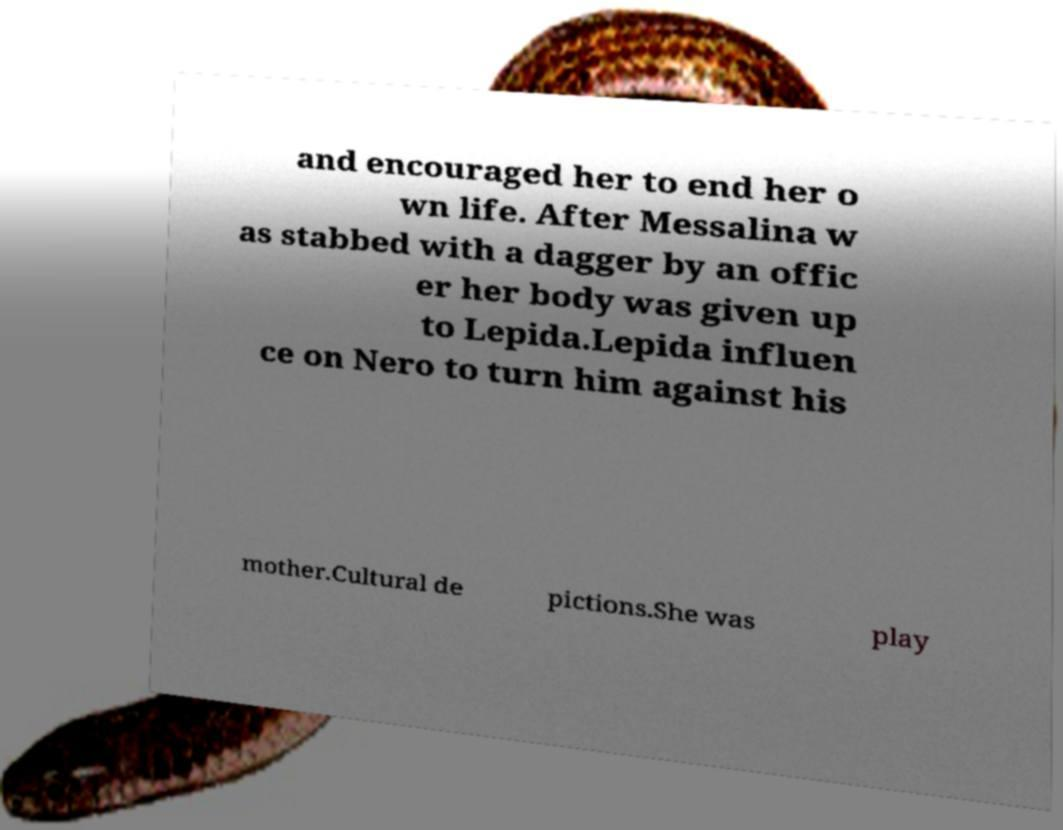Can you read and provide the text displayed in the image?This photo seems to have some interesting text. Can you extract and type it out for me? and encouraged her to end her o wn life. After Messalina w as stabbed with a dagger by an offic er her body was given up to Lepida.Lepida influen ce on Nero to turn him against his mother.Cultural de pictions.She was play 